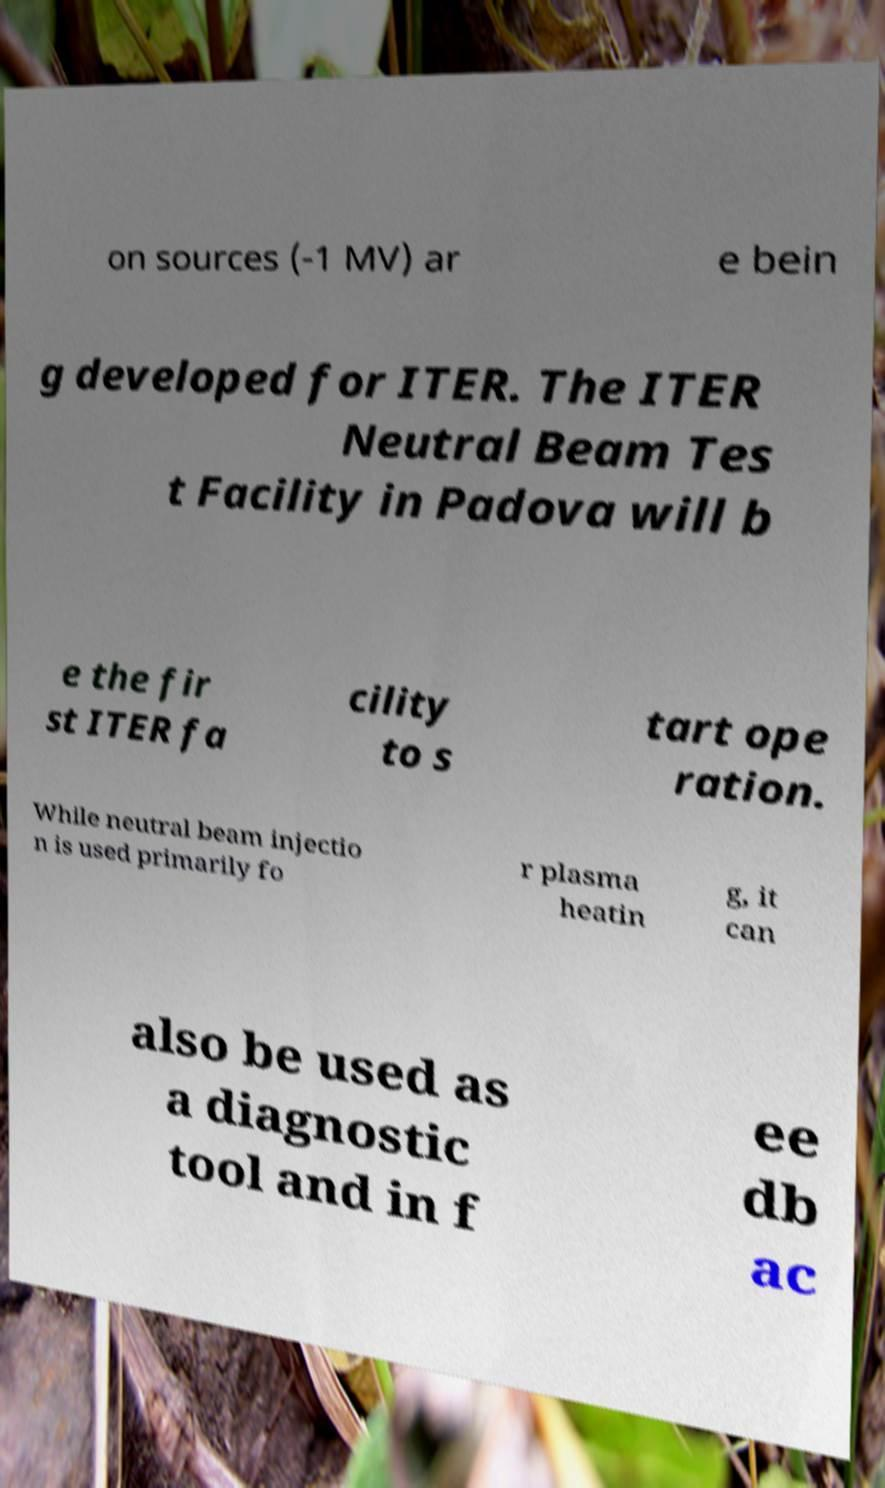Could you assist in decoding the text presented in this image and type it out clearly? on sources (-1 MV) ar e bein g developed for ITER. The ITER Neutral Beam Tes t Facility in Padova will b e the fir st ITER fa cility to s tart ope ration. While neutral beam injectio n is used primarily fo r plasma heatin g, it can also be used as a diagnostic tool and in f ee db ac 